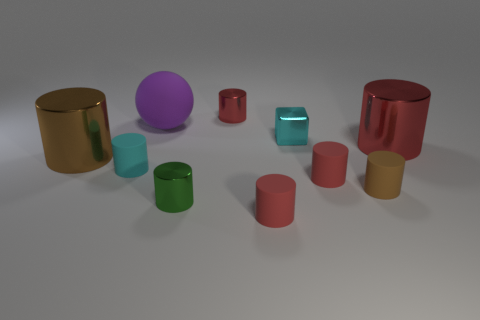Subtract all red cylinders. How many were subtracted if there are2red cylinders left? 2 Subtract all yellow balls. How many red cylinders are left? 4 Subtract all green cylinders. How many cylinders are left? 7 Subtract all cyan matte cylinders. How many cylinders are left? 7 Subtract 4 cylinders. How many cylinders are left? 4 Subtract all blue cylinders. Subtract all gray cubes. How many cylinders are left? 8 Subtract all spheres. How many objects are left? 9 Add 1 purple balls. How many purple balls are left? 2 Add 2 big matte spheres. How many big matte spheres exist? 3 Subtract 0 purple cylinders. How many objects are left? 10 